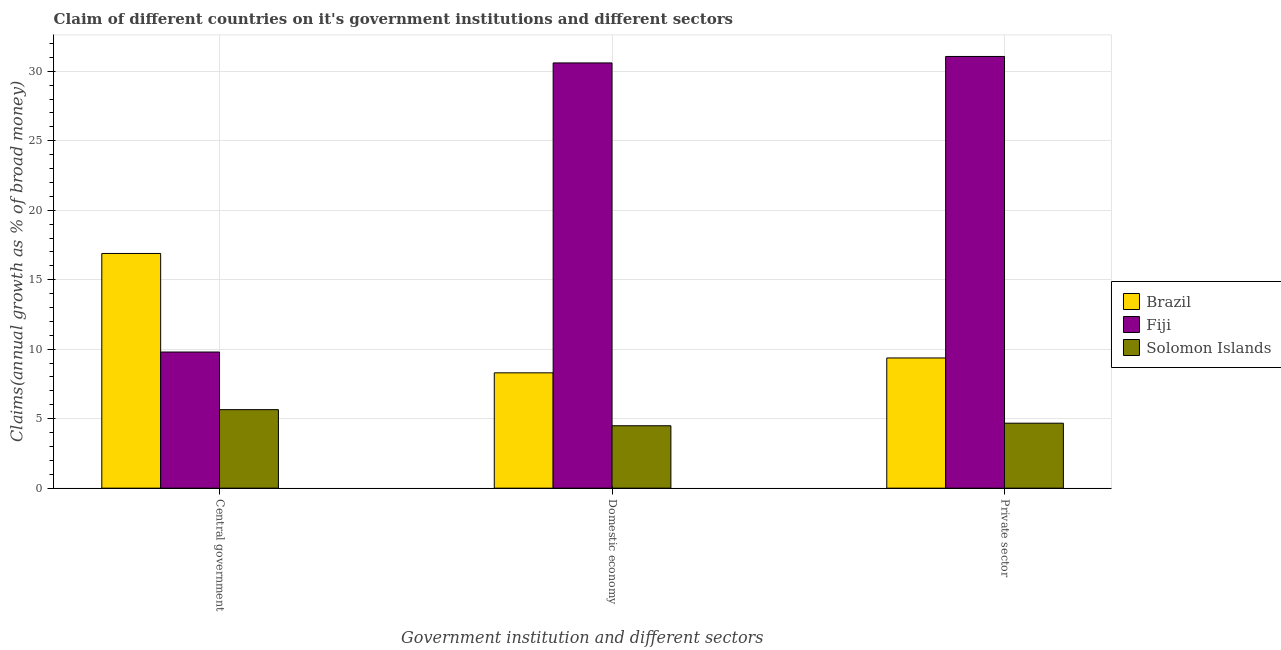How many groups of bars are there?
Offer a very short reply. 3. Are the number of bars per tick equal to the number of legend labels?
Offer a terse response. Yes. Are the number of bars on each tick of the X-axis equal?
Make the answer very short. Yes. How many bars are there on the 3rd tick from the right?
Your answer should be very brief. 3. What is the label of the 3rd group of bars from the left?
Make the answer very short. Private sector. What is the percentage of claim on the domestic economy in Solomon Islands?
Your response must be concise. 4.49. Across all countries, what is the maximum percentage of claim on the domestic economy?
Make the answer very short. 30.6. Across all countries, what is the minimum percentage of claim on the domestic economy?
Provide a succinct answer. 4.49. In which country was the percentage of claim on the private sector maximum?
Give a very brief answer. Fiji. In which country was the percentage of claim on the central government minimum?
Ensure brevity in your answer.  Solomon Islands. What is the total percentage of claim on the private sector in the graph?
Provide a succinct answer. 45.11. What is the difference between the percentage of claim on the domestic economy in Brazil and that in Fiji?
Provide a succinct answer. -22.3. What is the difference between the percentage of claim on the domestic economy in Solomon Islands and the percentage of claim on the private sector in Fiji?
Offer a very short reply. -26.58. What is the average percentage of claim on the domestic economy per country?
Your response must be concise. 14.46. What is the difference between the percentage of claim on the central government and percentage of claim on the domestic economy in Brazil?
Ensure brevity in your answer.  8.59. In how many countries, is the percentage of claim on the central government greater than 22 %?
Give a very brief answer. 0. What is the ratio of the percentage of claim on the private sector in Fiji to that in Brazil?
Your answer should be compact. 3.32. Is the percentage of claim on the domestic economy in Fiji less than that in Brazil?
Ensure brevity in your answer.  No. What is the difference between the highest and the second highest percentage of claim on the central government?
Offer a terse response. 7.09. What is the difference between the highest and the lowest percentage of claim on the domestic economy?
Offer a very short reply. 26.11. In how many countries, is the percentage of claim on the private sector greater than the average percentage of claim on the private sector taken over all countries?
Make the answer very short. 1. Is the sum of the percentage of claim on the central government in Fiji and Solomon Islands greater than the maximum percentage of claim on the domestic economy across all countries?
Make the answer very short. No. What does the 3rd bar from the left in Private sector represents?
Provide a succinct answer. Solomon Islands. What does the 3rd bar from the right in Central government represents?
Your answer should be compact. Brazil. Is it the case that in every country, the sum of the percentage of claim on the central government and percentage of claim on the domestic economy is greater than the percentage of claim on the private sector?
Provide a short and direct response. Yes. Are all the bars in the graph horizontal?
Your response must be concise. No. Are the values on the major ticks of Y-axis written in scientific E-notation?
Offer a very short reply. No. Does the graph contain any zero values?
Your answer should be very brief. No. Does the graph contain grids?
Offer a very short reply. Yes. What is the title of the graph?
Your answer should be compact. Claim of different countries on it's government institutions and different sectors. What is the label or title of the X-axis?
Offer a very short reply. Government institution and different sectors. What is the label or title of the Y-axis?
Provide a short and direct response. Claims(annual growth as % of broad money). What is the Claims(annual growth as % of broad money) of Brazil in Central government?
Your answer should be compact. 16.89. What is the Claims(annual growth as % of broad money) of Fiji in Central government?
Provide a short and direct response. 9.8. What is the Claims(annual growth as % of broad money) of Solomon Islands in Central government?
Make the answer very short. 5.65. What is the Claims(annual growth as % of broad money) of Brazil in Domestic economy?
Provide a short and direct response. 8.3. What is the Claims(annual growth as % of broad money) of Fiji in Domestic economy?
Provide a short and direct response. 30.6. What is the Claims(annual growth as % of broad money) of Solomon Islands in Domestic economy?
Provide a succinct answer. 4.49. What is the Claims(annual growth as % of broad money) of Brazil in Private sector?
Provide a succinct answer. 9.37. What is the Claims(annual growth as % of broad money) of Fiji in Private sector?
Your answer should be compact. 31.07. What is the Claims(annual growth as % of broad money) in Solomon Islands in Private sector?
Make the answer very short. 4.68. Across all Government institution and different sectors, what is the maximum Claims(annual growth as % of broad money) in Brazil?
Offer a terse response. 16.89. Across all Government institution and different sectors, what is the maximum Claims(annual growth as % of broad money) of Fiji?
Give a very brief answer. 31.07. Across all Government institution and different sectors, what is the maximum Claims(annual growth as % of broad money) in Solomon Islands?
Your answer should be very brief. 5.65. Across all Government institution and different sectors, what is the minimum Claims(annual growth as % of broad money) of Brazil?
Keep it short and to the point. 8.3. Across all Government institution and different sectors, what is the minimum Claims(annual growth as % of broad money) of Fiji?
Provide a short and direct response. 9.8. Across all Government institution and different sectors, what is the minimum Claims(annual growth as % of broad money) in Solomon Islands?
Provide a short and direct response. 4.49. What is the total Claims(annual growth as % of broad money) in Brazil in the graph?
Offer a terse response. 34.56. What is the total Claims(annual growth as % of broad money) of Fiji in the graph?
Keep it short and to the point. 71.47. What is the total Claims(annual growth as % of broad money) in Solomon Islands in the graph?
Offer a very short reply. 14.82. What is the difference between the Claims(annual growth as % of broad money) in Brazil in Central government and that in Domestic economy?
Ensure brevity in your answer.  8.59. What is the difference between the Claims(annual growth as % of broad money) in Fiji in Central government and that in Domestic economy?
Make the answer very short. -20.81. What is the difference between the Claims(annual growth as % of broad money) in Solomon Islands in Central government and that in Domestic economy?
Make the answer very short. 1.16. What is the difference between the Claims(annual growth as % of broad money) of Brazil in Central government and that in Private sector?
Make the answer very short. 7.52. What is the difference between the Claims(annual growth as % of broad money) in Fiji in Central government and that in Private sector?
Your response must be concise. -21.27. What is the difference between the Claims(annual growth as % of broad money) of Solomon Islands in Central government and that in Private sector?
Your response must be concise. 0.97. What is the difference between the Claims(annual growth as % of broad money) in Brazil in Domestic economy and that in Private sector?
Your answer should be very brief. -1.07. What is the difference between the Claims(annual growth as % of broad money) of Fiji in Domestic economy and that in Private sector?
Offer a very short reply. -0.47. What is the difference between the Claims(annual growth as % of broad money) of Solomon Islands in Domestic economy and that in Private sector?
Your answer should be compact. -0.18. What is the difference between the Claims(annual growth as % of broad money) of Brazil in Central government and the Claims(annual growth as % of broad money) of Fiji in Domestic economy?
Make the answer very short. -13.71. What is the difference between the Claims(annual growth as % of broad money) in Brazil in Central government and the Claims(annual growth as % of broad money) in Solomon Islands in Domestic economy?
Provide a short and direct response. 12.4. What is the difference between the Claims(annual growth as % of broad money) in Fiji in Central government and the Claims(annual growth as % of broad money) in Solomon Islands in Domestic economy?
Ensure brevity in your answer.  5.31. What is the difference between the Claims(annual growth as % of broad money) of Brazil in Central government and the Claims(annual growth as % of broad money) of Fiji in Private sector?
Keep it short and to the point. -14.18. What is the difference between the Claims(annual growth as % of broad money) in Brazil in Central government and the Claims(annual growth as % of broad money) in Solomon Islands in Private sector?
Offer a very short reply. 12.22. What is the difference between the Claims(annual growth as % of broad money) of Fiji in Central government and the Claims(annual growth as % of broad money) of Solomon Islands in Private sector?
Your response must be concise. 5.12. What is the difference between the Claims(annual growth as % of broad money) of Brazil in Domestic economy and the Claims(annual growth as % of broad money) of Fiji in Private sector?
Make the answer very short. -22.77. What is the difference between the Claims(annual growth as % of broad money) of Brazil in Domestic economy and the Claims(annual growth as % of broad money) of Solomon Islands in Private sector?
Your response must be concise. 3.62. What is the difference between the Claims(annual growth as % of broad money) in Fiji in Domestic economy and the Claims(annual growth as % of broad money) in Solomon Islands in Private sector?
Offer a terse response. 25.93. What is the average Claims(annual growth as % of broad money) of Brazil per Government institution and different sectors?
Keep it short and to the point. 11.52. What is the average Claims(annual growth as % of broad money) of Fiji per Government institution and different sectors?
Make the answer very short. 23.82. What is the average Claims(annual growth as % of broad money) of Solomon Islands per Government institution and different sectors?
Provide a short and direct response. 4.94. What is the difference between the Claims(annual growth as % of broad money) of Brazil and Claims(annual growth as % of broad money) of Fiji in Central government?
Offer a terse response. 7.09. What is the difference between the Claims(annual growth as % of broad money) of Brazil and Claims(annual growth as % of broad money) of Solomon Islands in Central government?
Offer a terse response. 11.24. What is the difference between the Claims(annual growth as % of broad money) in Fiji and Claims(annual growth as % of broad money) in Solomon Islands in Central government?
Provide a short and direct response. 4.15. What is the difference between the Claims(annual growth as % of broad money) of Brazil and Claims(annual growth as % of broad money) of Fiji in Domestic economy?
Offer a terse response. -22.3. What is the difference between the Claims(annual growth as % of broad money) of Brazil and Claims(annual growth as % of broad money) of Solomon Islands in Domestic economy?
Provide a succinct answer. 3.81. What is the difference between the Claims(annual growth as % of broad money) in Fiji and Claims(annual growth as % of broad money) in Solomon Islands in Domestic economy?
Give a very brief answer. 26.11. What is the difference between the Claims(annual growth as % of broad money) in Brazil and Claims(annual growth as % of broad money) in Fiji in Private sector?
Keep it short and to the point. -21.7. What is the difference between the Claims(annual growth as % of broad money) in Brazil and Claims(annual growth as % of broad money) in Solomon Islands in Private sector?
Keep it short and to the point. 4.7. What is the difference between the Claims(annual growth as % of broad money) of Fiji and Claims(annual growth as % of broad money) of Solomon Islands in Private sector?
Provide a succinct answer. 26.39. What is the ratio of the Claims(annual growth as % of broad money) in Brazil in Central government to that in Domestic economy?
Provide a short and direct response. 2.04. What is the ratio of the Claims(annual growth as % of broad money) of Fiji in Central government to that in Domestic economy?
Offer a very short reply. 0.32. What is the ratio of the Claims(annual growth as % of broad money) of Solomon Islands in Central government to that in Domestic economy?
Your response must be concise. 1.26. What is the ratio of the Claims(annual growth as % of broad money) of Brazil in Central government to that in Private sector?
Ensure brevity in your answer.  1.8. What is the ratio of the Claims(annual growth as % of broad money) in Fiji in Central government to that in Private sector?
Your response must be concise. 0.32. What is the ratio of the Claims(annual growth as % of broad money) of Solomon Islands in Central government to that in Private sector?
Provide a succinct answer. 1.21. What is the ratio of the Claims(annual growth as % of broad money) in Brazil in Domestic economy to that in Private sector?
Your answer should be compact. 0.89. What is the ratio of the Claims(annual growth as % of broad money) of Fiji in Domestic economy to that in Private sector?
Keep it short and to the point. 0.98. What is the ratio of the Claims(annual growth as % of broad money) of Solomon Islands in Domestic economy to that in Private sector?
Your answer should be compact. 0.96. What is the difference between the highest and the second highest Claims(annual growth as % of broad money) of Brazil?
Give a very brief answer. 7.52. What is the difference between the highest and the second highest Claims(annual growth as % of broad money) of Fiji?
Provide a short and direct response. 0.47. What is the difference between the highest and the second highest Claims(annual growth as % of broad money) of Solomon Islands?
Provide a short and direct response. 0.97. What is the difference between the highest and the lowest Claims(annual growth as % of broad money) of Brazil?
Ensure brevity in your answer.  8.59. What is the difference between the highest and the lowest Claims(annual growth as % of broad money) in Fiji?
Ensure brevity in your answer.  21.27. What is the difference between the highest and the lowest Claims(annual growth as % of broad money) in Solomon Islands?
Provide a succinct answer. 1.16. 